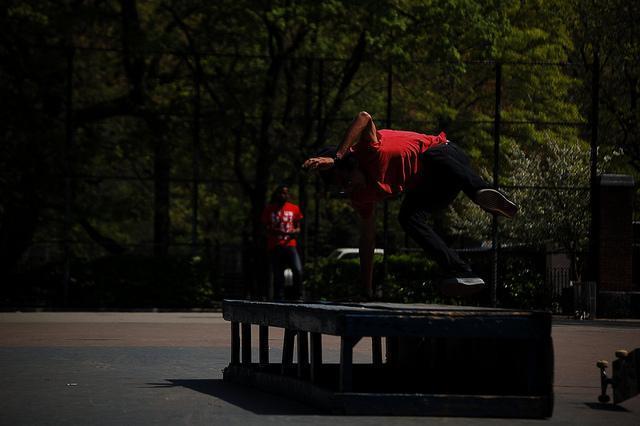How many people are visible?
Give a very brief answer. 2. 